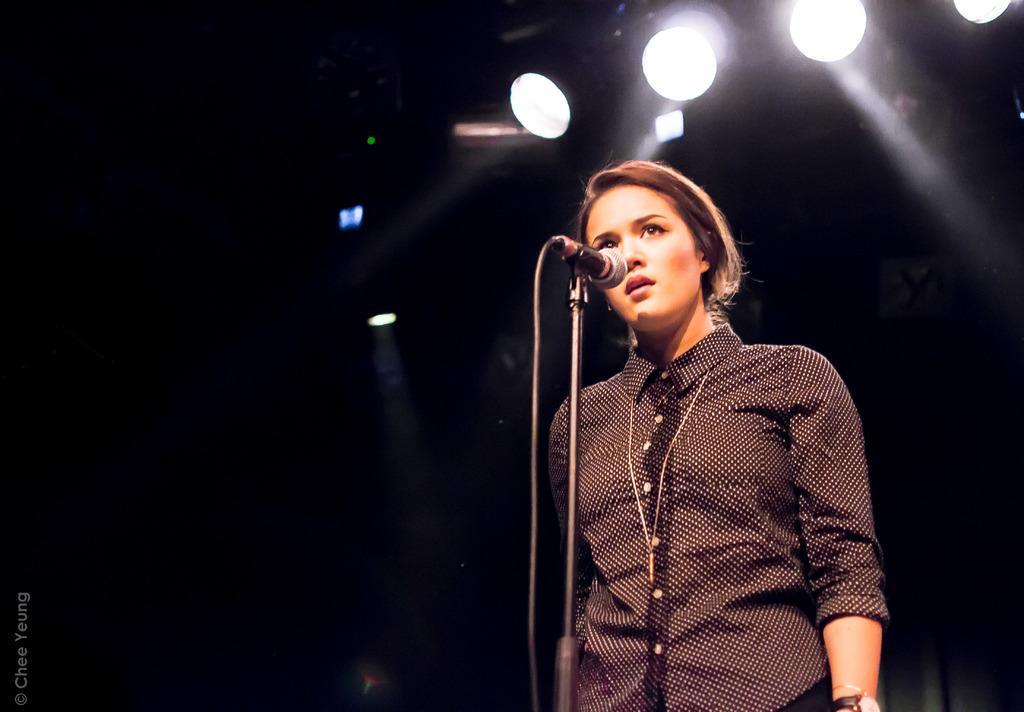Describe this image in one or two sentences. In this picture there is a woman standing in front of a mic and a stand. She is wearing a shirt. In the background we can observe four white color lights and it is completely dark. We can observe a watermark on the left side. 